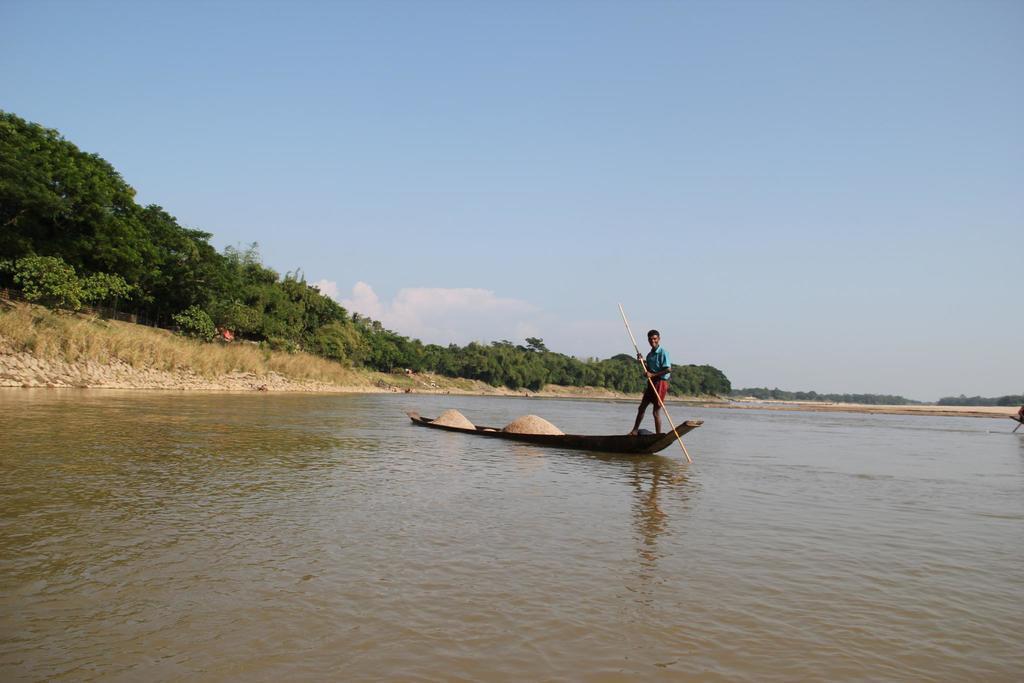Describe this image in one or two sentences. In this picture there is a man who is wearing t-shirt and short. He is standing on the boat and he is holding a stick. On the bottom we can see water. On the background we can see trees and grass. On the top we can see sky and clouds. 